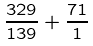<formula> <loc_0><loc_0><loc_500><loc_500>\frac { 3 2 9 } { 1 3 9 } + \frac { 7 1 } { 1 }</formula> 